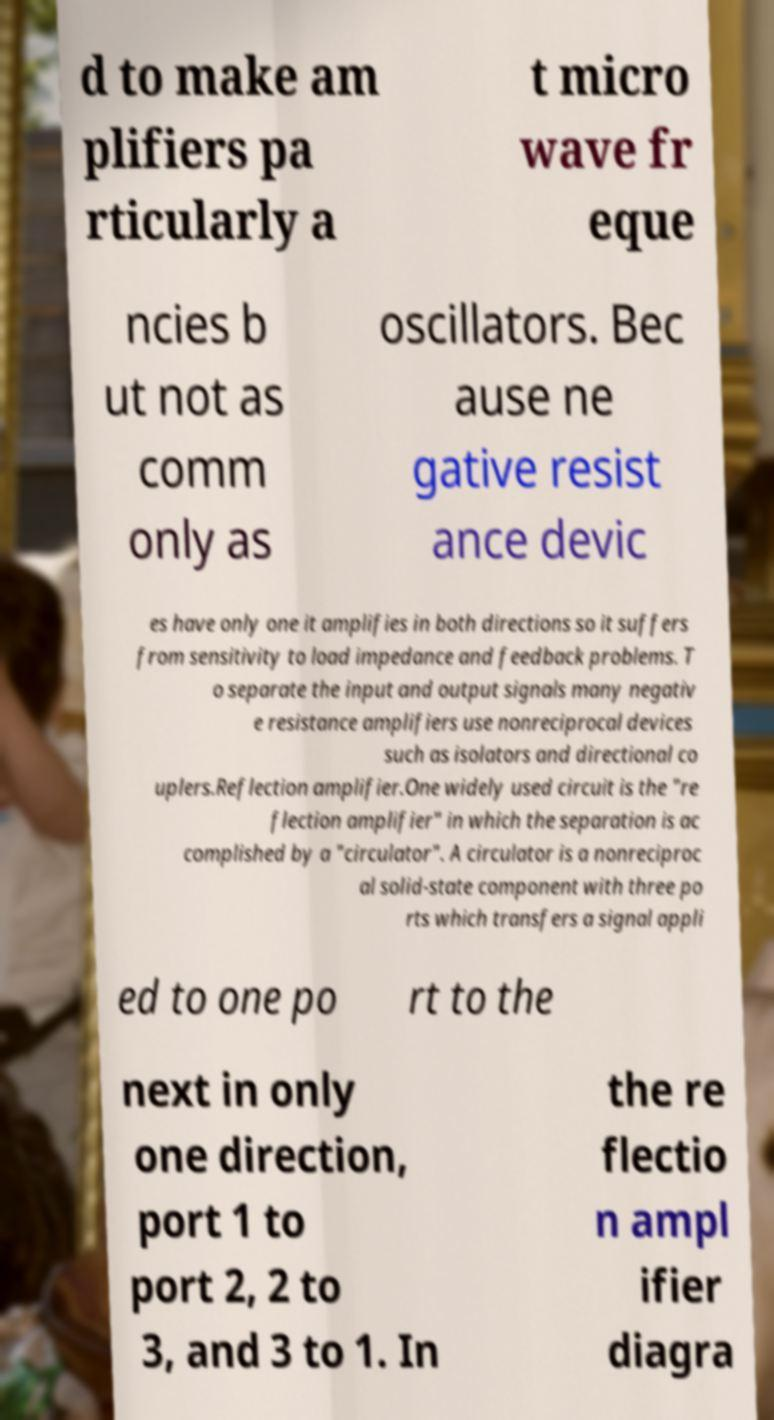What messages or text are displayed in this image? I need them in a readable, typed format. d to make am plifiers pa rticularly a t micro wave fr eque ncies b ut not as comm only as oscillators. Bec ause ne gative resist ance devic es have only one it amplifies in both directions so it suffers from sensitivity to load impedance and feedback problems. T o separate the input and output signals many negativ e resistance amplifiers use nonreciprocal devices such as isolators and directional co uplers.Reflection amplifier.One widely used circuit is the "re flection amplifier" in which the separation is ac complished by a "circulator". A circulator is a nonreciproc al solid-state component with three po rts which transfers a signal appli ed to one po rt to the next in only one direction, port 1 to port 2, 2 to 3, and 3 to 1. In the re flectio n ampl ifier diagra 